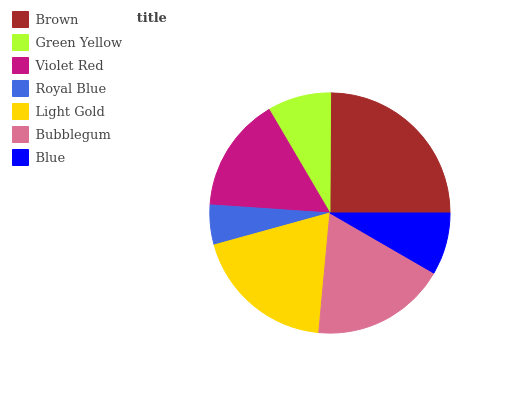Is Royal Blue the minimum?
Answer yes or no. Yes. Is Brown the maximum?
Answer yes or no. Yes. Is Green Yellow the minimum?
Answer yes or no. No. Is Green Yellow the maximum?
Answer yes or no. No. Is Brown greater than Green Yellow?
Answer yes or no. Yes. Is Green Yellow less than Brown?
Answer yes or no. Yes. Is Green Yellow greater than Brown?
Answer yes or no. No. Is Brown less than Green Yellow?
Answer yes or no. No. Is Violet Red the high median?
Answer yes or no. Yes. Is Violet Red the low median?
Answer yes or no. Yes. Is Light Gold the high median?
Answer yes or no. No. Is Bubblegum the low median?
Answer yes or no. No. 